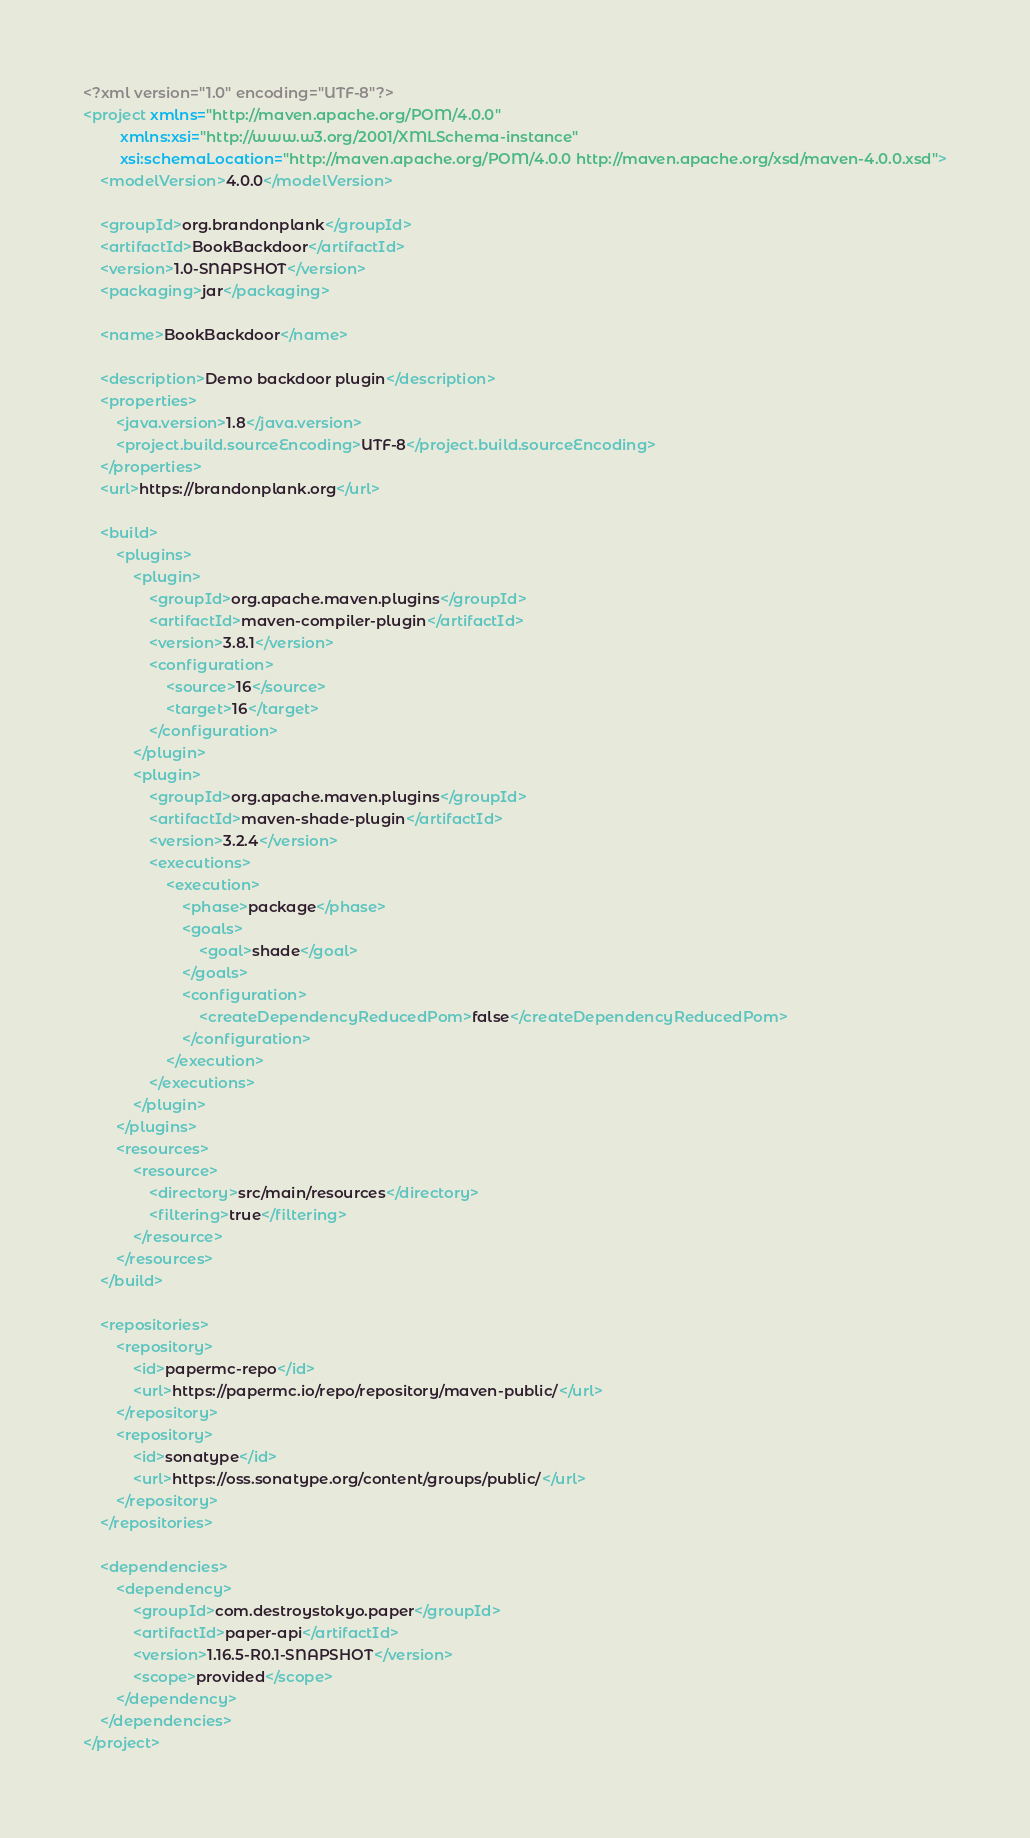<code> <loc_0><loc_0><loc_500><loc_500><_XML_><?xml version="1.0" encoding="UTF-8"?>
<project xmlns="http://maven.apache.org/POM/4.0.0"
         xmlns:xsi="http://www.w3.org/2001/XMLSchema-instance"
         xsi:schemaLocation="http://maven.apache.org/POM/4.0.0 http://maven.apache.org/xsd/maven-4.0.0.xsd">
    <modelVersion>4.0.0</modelVersion>

    <groupId>org.brandonplank</groupId>
    <artifactId>BookBackdoor</artifactId>
    <version>1.0-SNAPSHOT</version>
    <packaging>jar</packaging>

    <name>BookBackdoor</name>

    <description>Demo backdoor plugin</description>
    <properties>
        <java.version>1.8</java.version>
        <project.build.sourceEncoding>UTF-8</project.build.sourceEncoding>
    </properties>
    <url>https://brandonplank.org</url>

    <build>
        <plugins>
            <plugin>
                <groupId>org.apache.maven.plugins</groupId>
                <artifactId>maven-compiler-plugin</artifactId>
                <version>3.8.1</version>
                <configuration>
                    <source>16</source>
                    <target>16</target>
                </configuration>
            </plugin>
            <plugin>
                <groupId>org.apache.maven.plugins</groupId>
                <artifactId>maven-shade-plugin</artifactId>
                <version>3.2.4</version>
                <executions>
                    <execution>
                        <phase>package</phase>
                        <goals>
                            <goal>shade</goal>
                        </goals>
                        <configuration>
                            <createDependencyReducedPom>false</createDependencyReducedPom>
                        </configuration>
                    </execution>
                </executions>
            </plugin>
        </plugins>
        <resources>
            <resource>
                <directory>src/main/resources</directory>
                <filtering>true</filtering>
            </resource>
        </resources>
    </build>

    <repositories>
        <repository>
            <id>papermc-repo</id>
            <url>https://papermc.io/repo/repository/maven-public/</url>
        </repository>
        <repository>
            <id>sonatype</id>
            <url>https://oss.sonatype.org/content/groups/public/</url>
        </repository>
    </repositories>

    <dependencies>
        <dependency>
            <groupId>com.destroystokyo.paper</groupId>
            <artifactId>paper-api</artifactId>
            <version>1.16.5-R0.1-SNAPSHOT</version>
            <scope>provided</scope>
        </dependency>
    </dependencies>
</project>
</code> 